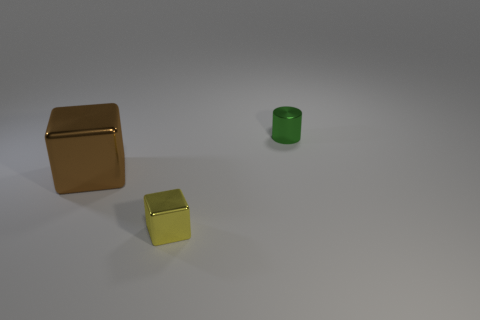Add 1 purple metallic balls. How many objects exist? 4 Subtract all blocks. How many objects are left? 1 Subtract all yellow cubes. Subtract all yellow things. How many objects are left? 1 Add 1 big cubes. How many big cubes are left? 2 Add 1 blocks. How many blocks exist? 3 Subtract 0 yellow spheres. How many objects are left? 3 